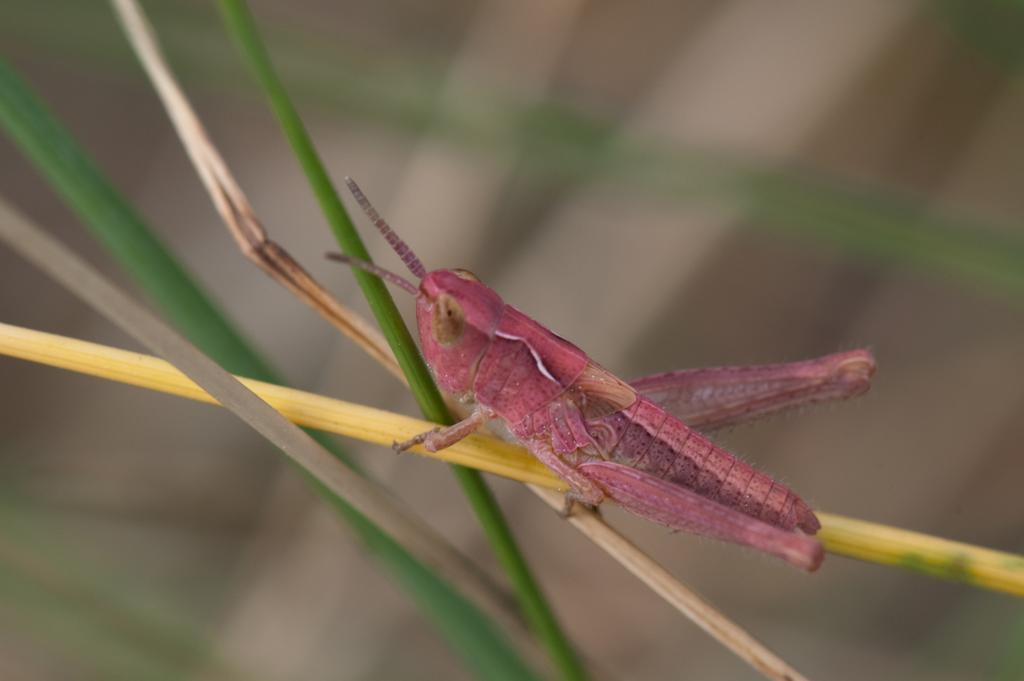What is the main subject of the image? There is an insect in the image. Where is the insect located? The insect is on a stem. What color is the insect? The insect is red in color. Can you describe the background of the image? The background of the image is blurred. How does the insect attack the dirt in the image? There is no dirt present in the image, and the insect is not attacking anything. 